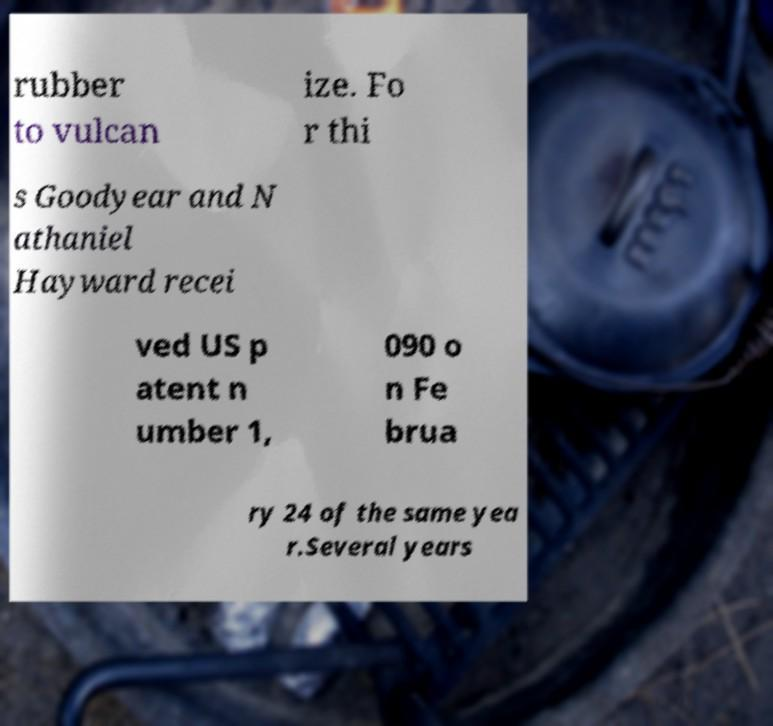Please read and relay the text visible in this image. What does it say? rubber to vulcan ize. Fo r thi s Goodyear and N athaniel Hayward recei ved US p atent n umber 1, 090 o n Fe brua ry 24 of the same yea r.Several years 